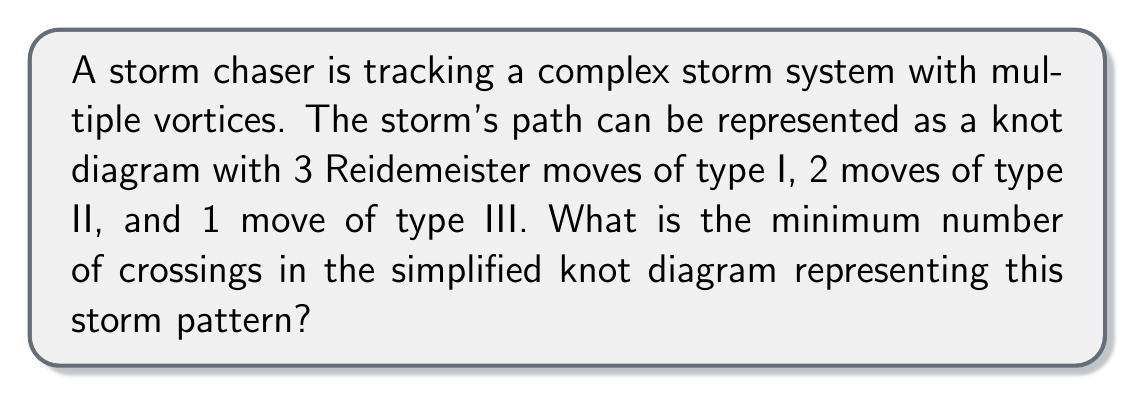Teach me how to tackle this problem. To solve this problem, we need to understand how Reidemeister moves affect the number of crossings in a knot diagram:

1. Reidemeister move type I: Removes or adds a twist (1 crossing)
2. Reidemeister move type II: Removes or adds 2 crossings
3. Reidemeister move type III: Rearranges 3 strands without changing the number of crossings

Step 1: Calculate the change in crossings due to type I moves:
$$ \text{Change from type I} = 3 \times 1 = 3 $$

Step 2: Calculate the change in crossings due to type II moves:
$$ \text{Change from type II} = 2 \times 2 = 4 $$

Step 3: Type III moves don't change the number of crossings, so we can ignore them.

Step 4: Sum up the total change in crossings:
$$ \text{Total change} = 3 + 4 = 7 $$

Step 5: The minimum number of crossings in the simplified knot diagram is the total change we calculated. This is because the Reidemeister moves are used to simplify the knot diagram, and the minimum number of crossings occurs when all possible simplifications have been made.

Therefore, the minimum number of crossings in the simplified knot diagram representing this storm pattern is 7.
Answer: 7 crossings 